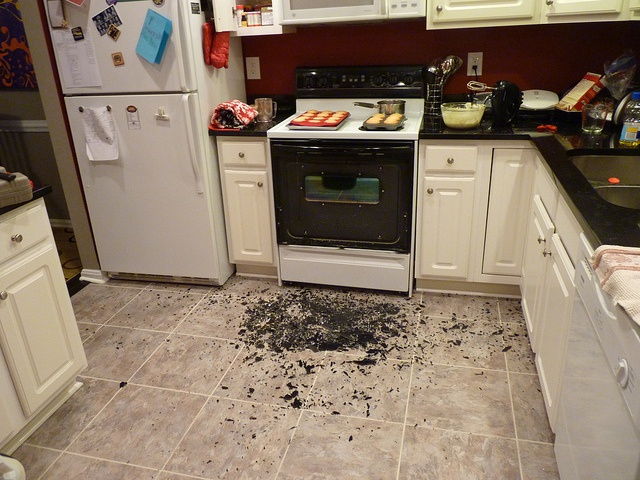Describe the objects in this image and their specific colors. I can see refrigerator in black, darkgray, gray, and tan tones, oven in black, darkgray, and tan tones, sink in black, darkgreen, and red tones, microwave in black, lightgray, beige, gray, and darkgray tones, and bowl in black, tan, and khaki tones in this image. 